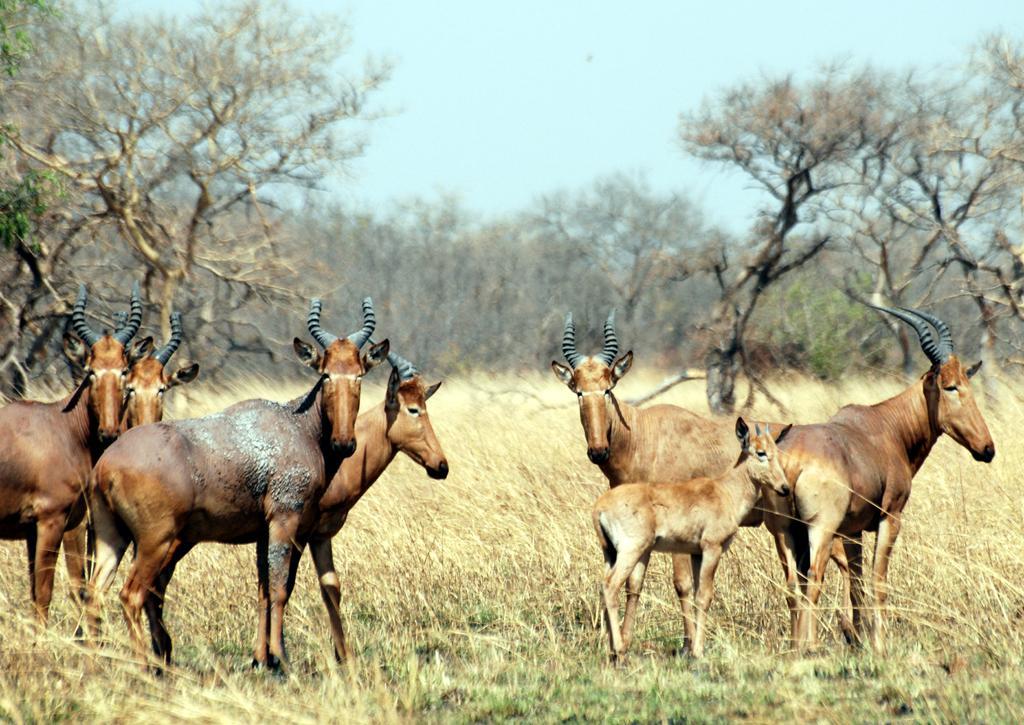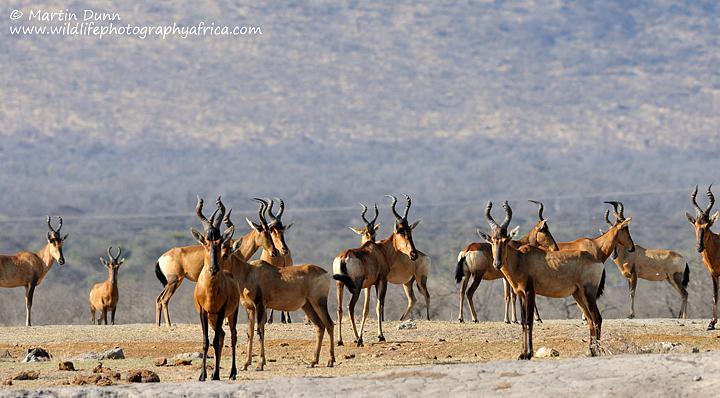The first image is the image on the left, the second image is the image on the right. For the images displayed, is the sentence "There is only one animal in one of the images." factually correct? Answer yes or no. No. The first image is the image on the left, the second image is the image on the right. Analyze the images presented: Is the assertion "An image contains just one horned animal in a field." valid? Answer yes or no. No. 